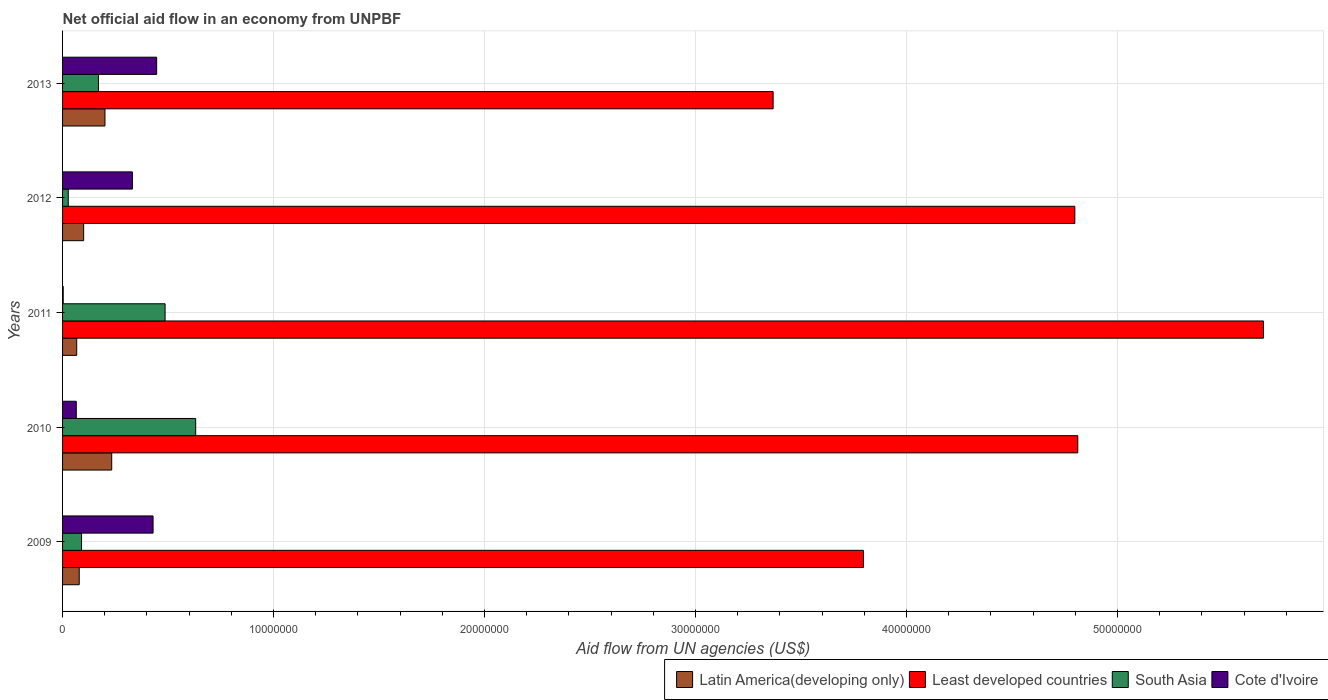How many different coloured bars are there?
Make the answer very short. 4. Are the number of bars on each tick of the Y-axis equal?
Offer a very short reply. Yes. How many bars are there on the 5th tick from the top?
Ensure brevity in your answer.  4. In how many cases, is the number of bars for a given year not equal to the number of legend labels?
Provide a succinct answer. 0. What is the net official aid flow in Least developed countries in 2012?
Make the answer very short. 4.80e+07. Across all years, what is the maximum net official aid flow in South Asia?
Provide a succinct answer. 6.31e+06. Across all years, what is the minimum net official aid flow in South Asia?
Your response must be concise. 2.70e+05. In which year was the net official aid flow in Least developed countries maximum?
Provide a short and direct response. 2011. In which year was the net official aid flow in Cote d'Ivoire minimum?
Provide a succinct answer. 2011. What is the total net official aid flow in Cote d'Ivoire in the graph?
Ensure brevity in your answer.  1.27e+07. What is the difference between the net official aid flow in Latin America(developing only) in 2010 and that in 2011?
Your response must be concise. 1.66e+06. What is the difference between the net official aid flow in Latin America(developing only) in 2010 and the net official aid flow in South Asia in 2013?
Offer a terse response. 6.30e+05. What is the average net official aid flow in Least developed countries per year?
Offer a very short reply. 4.49e+07. In the year 2009, what is the difference between the net official aid flow in Cote d'Ivoire and net official aid flow in Least developed countries?
Provide a succinct answer. -3.37e+07. In how many years, is the net official aid flow in Latin America(developing only) greater than 26000000 US$?
Your response must be concise. 0. What is the ratio of the net official aid flow in Least developed countries in 2010 to that in 2012?
Keep it short and to the point. 1. Is the net official aid flow in Cote d'Ivoire in 2012 less than that in 2013?
Your response must be concise. Yes. What is the difference between the highest and the second highest net official aid flow in Cote d'Ivoire?
Your answer should be very brief. 1.70e+05. What is the difference between the highest and the lowest net official aid flow in Cote d'Ivoire?
Provide a succinct answer. 4.43e+06. In how many years, is the net official aid flow in Cote d'Ivoire greater than the average net official aid flow in Cote d'Ivoire taken over all years?
Ensure brevity in your answer.  3. Is the sum of the net official aid flow in Cote d'Ivoire in 2009 and 2010 greater than the maximum net official aid flow in Least developed countries across all years?
Your answer should be very brief. No. What does the 1st bar from the top in 2009 represents?
Provide a short and direct response. Cote d'Ivoire. What does the 1st bar from the bottom in 2012 represents?
Provide a short and direct response. Latin America(developing only). Is it the case that in every year, the sum of the net official aid flow in South Asia and net official aid flow in Latin America(developing only) is greater than the net official aid flow in Cote d'Ivoire?
Offer a very short reply. No. Are all the bars in the graph horizontal?
Offer a terse response. Yes. How many years are there in the graph?
Your response must be concise. 5. Does the graph contain grids?
Offer a terse response. Yes. How many legend labels are there?
Your answer should be compact. 4. What is the title of the graph?
Give a very brief answer. Net official aid flow in an economy from UNPBF. What is the label or title of the X-axis?
Keep it short and to the point. Aid flow from UN agencies (US$). What is the label or title of the Y-axis?
Your answer should be compact. Years. What is the Aid flow from UN agencies (US$) in Latin America(developing only) in 2009?
Provide a short and direct response. 7.90e+05. What is the Aid flow from UN agencies (US$) in Least developed countries in 2009?
Keep it short and to the point. 3.80e+07. What is the Aid flow from UN agencies (US$) in South Asia in 2009?
Provide a succinct answer. 9.00e+05. What is the Aid flow from UN agencies (US$) of Cote d'Ivoire in 2009?
Your answer should be very brief. 4.29e+06. What is the Aid flow from UN agencies (US$) in Latin America(developing only) in 2010?
Provide a short and direct response. 2.33e+06. What is the Aid flow from UN agencies (US$) of Least developed countries in 2010?
Keep it short and to the point. 4.81e+07. What is the Aid flow from UN agencies (US$) of South Asia in 2010?
Offer a terse response. 6.31e+06. What is the Aid flow from UN agencies (US$) in Cote d'Ivoire in 2010?
Your answer should be compact. 6.50e+05. What is the Aid flow from UN agencies (US$) of Latin America(developing only) in 2011?
Your answer should be very brief. 6.70e+05. What is the Aid flow from UN agencies (US$) in Least developed countries in 2011?
Make the answer very short. 5.69e+07. What is the Aid flow from UN agencies (US$) of South Asia in 2011?
Make the answer very short. 4.86e+06. What is the Aid flow from UN agencies (US$) in Latin America(developing only) in 2012?
Make the answer very short. 1.00e+06. What is the Aid flow from UN agencies (US$) of Least developed countries in 2012?
Your answer should be very brief. 4.80e+07. What is the Aid flow from UN agencies (US$) in South Asia in 2012?
Give a very brief answer. 2.70e+05. What is the Aid flow from UN agencies (US$) in Cote d'Ivoire in 2012?
Provide a short and direct response. 3.31e+06. What is the Aid flow from UN agencies (US$) in Latin America(developing only) in 2013?
Provide a short and direct response. 2.01e+06. What is the Aid flow from UN agencies (US$) in Least developed countries in 2013?
Offer a terse response. 3.37e+07. What is the Aid flow from UN agencies (US$) in South Asia in 2013?
Offer a very short reply. 1.70e+06. What is the Aid flow from UN agencies (US$) of Cote d'Ivoire in 2013?
Offer a very short reply. 4.46e+06. Across all years, what is the maximum Aid flow from UN agencies (US$) of Latin America(developing only)?
Your response must be concise. 2.33e+06. Across all years, what is the maximum Aid flow from UN agencies (US$) in Least developed countries?
Give a very brief answer. 5.69e+07. Across all years, what is the maximum Aid flow from UN agencies (US$) of South Asia?
Ensure brevity in your answer.  6.31e+06. Across all years, what is the maximum Aid flow from UN agencies (US$) of Cote d'Ivoire?
Make the answer very short. 4.46e+06. Across all years, what is the minimum Aid flow from UN agencies (US$) in Latin America(developing only)?
Make the answer very short. 6.70e+05. Across all years, what is the minimum Aid flow from UN agencies (US$) of Least developed countries?
Your response must be concise. 3.37e+07. What is the total Aid flow from UN agencies (US$) in Latin America(developing only) in the graph?
Ensure brevity in your answer.  6.80e+06. What is the total Aid flow from UN agencies (US$) in Least developed countries in the graph?
Your answer should be very brief. 2.25e+08. What is the total Aid flow from UN agencies (US$) in South Asia in the graph?
Give a very brief answer. 1.40e+07. What is the total Aid flow from UN agencies (US$) of Cote d'Ivoire in the graph?
Provide a succinct answer. 1.27e+07. What is the difference between the Aid flow from UN agencies (US$) of Latin America(developing only) in 2009 and that in 2010?
Make the answer very short. -1.54e+06. What is the difference between the Aid flow from UN agencies (US$) in Least developed countries in 2009 and that in 2010?
Ensure brevity in your answer.  -1.02e+07. What is the difference between the Aid flow from UN agencies (US$) in South Asia in 2009 and that in 2010?
Your answer should be compact. -5.41e+06. What is the difference between the Aid flow from UN agencies (US$) in Cote d'Ivoire in 2009 and that in 2010?
Provide a short and direct response. 3.64e+06. What is the difference between the Aid flow from UN agencies (US$) of Latin America(developing only) in 2009 and that in 2011?
Offer a terse response. 1.20e+05. What is the difference between the Aid flow from UN agencies (US$) in Least developed countries in 2009 and that in 2011?
Your answer should be very brief. -1.90e+07. What is the difference between the Aid flow from UN agencies (US$) of South Asia in 2009 and that in 2011?
Ensure brevity in your answer.  -3.96e+06. What is the difference between the Aid flow from UN agencies (US$) of Cote d'Ivoire in 2009 and that in 2011?
Make the answer very short. 4.26e+06. What is the difference between the Aid flow from UN agencies (US$) in Latin America(developing only) in 2009 and that in 2012?
Your answer should be compact. -2.10e+05. What is the difference between the Aid flow from UN agencies (US$) in Least developed countries in 2009 and that in 2012?
Make the answer very short. -1.00e+07. What is the difference between the Aid flow from UN agencies (US$) of South Asia in 2009 and that in 2012?
Provide a succinct answer. 6.30e+05. What is the difference between the Aid flow from UN agencies (US$) in Cote d'Ivoire in 2009 and that in 2012?
Your answer should be compact. 9.80e+05. What is the difference between the Aid flow from UN agencies (US$) in Latin America(developing only) in 2009 and that in 2013?
Your response must be concise. -1.22e+06. What is the difference between the Aid flow from UN agencies (US$) in Least developed countries in 2009 and that in 2013?
Make the answer very short. 4.28e+06. What is the difference between the Aid flow from UN agencies (US$) of South Asia in 2009 and that in 2013?
Offer a terse response. -8.00e+05. What is the difference between the Aid flow from UN agencies (US$) in Cote d'Ivoire in 2009 and that in 2013?
Your response must be concise. -1.70e+05. What is the difference between the Aid flow from UN agencies (US$) of Latin America(developing only) in 2010 and that in 2011?
Give a very brief answer. 1.66e+06. What is the difference between the Aid flow from UN agencies (US$) in Least developed countries in 2010 and that in 2011?
Your answer should be very brief. -8.80e+06. What is the difference between the Aid flow from UN agencies (US$) in South Asia in 2010 and that in 2011?
Provide a short and direct response. 1.45e+06. What is the difference between the Aid flow from UN agencies (US$) of Cote d'Ivoire in 2010 and that in 2011?
Provide a short and direct response. 6.20e+05. What is the difference between the Aid flow from UN agencies (US$) of Latin America(developing only) in 2010 and that in 2012?
Keep it short and to the point. 1.33e+06. What is the difference between the Aid flow from UN agencies (US$) in South Asia in 2010 and that in 2012?
Provide a succinct answer. 6.04e+06. What is the difference between the Aid flow from UN agencies (US$) in Cote d'Ivoire in 2010 and that in 2012?
Offer a terse response. -2.66e+06. What is the difference between the Aid flow from UN agencies (US$) of Least developed countries in 2010 and that in 2013?
Give a very brief answer. 1.44e+07. What is the difference between the Aid flow from UN agencies (US$) in South Asia in 2010 and that in 2013?
Offer a terse response. 4.61e+06. What is the difference between the Aid flow from UN agencies (US$) in Cote d'Ivoire in 2010 and that in 2013?
Offer a terse response. -3.81e+06. What is the difference between the Aid flow from UN agencies (US$) in Latin America(developing only) in 2011 and that in 2012?
Your answer should be very brief. -3.30e+05. What is the difference between the Aid flow from UN agencies (US$) of Least developed countries in 2011 and that in 2012?
Make the answer very short. 8.94e+06. What is the difference between the Aid flow from UN agencies (US$) of South Asia in 2011 and that in 2012?
Ensure brevity in your answer.  4.59e+06. What is the difference between the Aid flow from UN agencies (US$) in Cote d'Ivoire in 2011 and that in 2012?
Provide a short and direct response. -3.28e+06. What is the difference between the Aid flow from UN agencies (US$) in Latin America(developing only) in 2011 and that in 2013?
Keep it short and to the point. -1.34e+06. What is the difference between the Aid flow from UN agencies (US$) of Least developed countries in 2011 and that in 2013?
Ensure brevity in your answer.  2.32e+07. What is the difference between the Aid flow from UN agencies (US$) of South Asia in 2011 and that in 2013?
Offer a very short reply. 3.16e+06. What is the difference between the Aid flow from UN agencies (US$) of Cote d'Ivoire in 2011 and that in 2013?
Provide a succinct answer. -4.43e+06. What is the difference between the Aid flow from UN agencies (US$) in Latin America(developing only) in 2012 and that in 2013?
Offer a very short reply. -1.01e+06. What is the difference between the Aid flow from UN agencies (US$) in Least developed countries in 2012 and that in 2013?
Offer a very short reply. 1.43e+07. What is the difference between the Aid flow from UN agencies (US$) of South Asia in 2012 and that in 2013?
Offer a terse response. -1.43e+06. What is the difference between the Aid flow from UN agencies (US$) of Cote d'Ivoire in 2012 and that in 2013?
Keep it short and to the point. -1.15e+06. What is the difference between the Aid flow from UN agencies (US$) in Latin America(developing only) in 2009 and the Aid flow from UN agencies (US$) in Least developed countries in 2010?
Provide a short and direct response. -4.73e+07. What is the difference between the Aid flow from UN agencies (US$) of Latin America(developing only) in 2009 and the Aid flow from UN agencies (US$) of South Asia in 2010?
Offer a terse response. -5.52e+06. What is the difference between the Aid flow from UN agencies (US$) of Latin America(developing only) in 2009 and the Aid flow from UN agencies (US$) of Cote d'Ivoire in 2010?
Give a very brief answer. 1.40e+05. What is the difference between the Aid flow from UN agencies (US$) in Least developed countries in 2009 and the Aid flow from UN agencies (US$) in South Asia in 2010?
Your answer should be compact. 3.16e+07. What is the difference between the Aid flow from UN agencies (US$) in Least developed countries in 2009 and the Aid flow from UN agencies (US$) in Cote d'Ivoire in 2010?
Ensure brevity in your answer.  3.73e+07. What is the difference between the Aid flow from UN agencies (US$) of South Asia in 2009 and the Aid flow from UN agencies (US$) of Cote d'Ivoire in 2010?
Your answer should be very brief. 2.50e+05. What is the difference between the Aid flow from UN agencies (US$) in Latin America(developing only) in 2009 and the Aid flow from UN agencies (US$) in Least developed countries in 2011?
Provide a short and direct response. -5.61e+07. What is the difference between the Aid flow from UN agencies (US$) of Latin America(developing only) in 2009 and the Aid flow from UN agencies (US$) of South Asia in 2011?
Make the answer very short. -4.07e+06. What is the difference between the Aid flow from UN agencies (US$) in Latin America(developing only) in 2009 and the Aid flow from UN agencies (US$) in Cote d'Ivoire in 2011?
Your answer should be very brief. 7.60e+05. What is the difference between the Aid flow from UN agencies (US$) in Least developed countries in 2009 and the Aid flow from UN agencies (US$) in South Asia in 2011?
Keep it short and to the point. 3.31e+07. What is the difference between the Aid flow from UN agencies (US$) in Least developed countries in 2009 and the Aid flow from UN agencies (US$) in Cote d'Ivoire in 2011?
Keep it short and to the point. 3.79e+07. What is the difference between the Aid flow from UN agencies (US$) in South Asia in 2009 and the Aid flow from UN agencies (US$) in Cote d'Ivoire in 2011?
Provide a short and direct response. 8.70e+05. What is the difference between the Aid flow from UN agencies (US$) of Latin America(developing only) in 2009 and the Aid flow from UN agencies (US$) of Least developed countries in 2012?
Ensure brevity in your answer.  -4.72e+07. What is the difference between the Aid flow from UN agencies (US$) in Latin America(developing only) in 2009 and the Aid flow from UN agencies (US$) in South Asia in 2012?
Your response must be concise. 5.20e+05. What is the difference between the Aid flow from UN agencies (US$) in Latin America(developing only) in 2009 and the Aid flow from UN agencies (US$) in Cote d'Ivoire in 2012?
Your response must be concise. -2.52e+06. What is the difference between the Aid flow from UN agencies (US$) in Least developed countries in 2009 and the Aid flow from UN agencies (US$) in South Asia in 2012?
Make the answer very short. 3.77e+07. What is the difference between the Aid flow from UN agencies (US$) in Least developed countries in 2009 and the Aid flow from UN agencies (US$) in Cote d'Ivoire in 2012?
Provide a short and direct response. 3.46e+07. What is the difference between the Aid flow from UN agencies (US$) in South Asia in 2009 and the Aid flow from UN agencies (US$) in Cote d'Ivoire in 2012?
Your answer should be compact. -2.41e+06. What is the difference between the Aid flow from UN agencies (US$) of Latin America(developing only) in 2009 and the Aid flow from UN agencies (US$) of Least developed countries in 2013?
Provide a succinct answer. -3.29e+07. What is the difference between the Aid flow from UN agencies (US$) in Latin America(developing only) in 2009 and the Aid flow from UN agencies (US$) in South Asia in 2013?
Ensure brevity in your answer.  -9.10e+05. What is the difference between the Aid flow from UN agencies (US$) in Latin America(developing only) in 2009 and the Aid flow from UN agencies (US$) in Cote d'Ivoire in 2013?
Offer a very short reply. -3.67e+06. What is the difference between the Aid flow from UN agencies (US$) in Least developed countries in 2009 and the Aid flow from UN agencies (US$) in South Asia in 2013?
Offer a very short reply. 3.63e+07. What is the difference between the Aid flow from UN agencies (US$) in Least developed countries in 2009 and the Aid flow from UN agencies (US$) in Cote d'Ivoire in 2013?
Your answer should be very brief. 3.35e+07. What is the difference between the Aid flow from UN agencies (US$) in South Asia in 2009 and the Aid flow from UN agencies (US$) in Cote d'Ivoire in 2013?
Provide a succinct answer. -3.56e+06. What is the difference between the Aid flow from UN agencies (US$) in Latin America(developing only) in 2010 and the Aid flow from UN agencies (US$) in Least developed countries in 2011?
Provide a short and direct response. -5.46e+07. What is the difference between the Aid flow from UN agencies (US$) of Latin America(developing only) in 2010 and the Aid flow from UN agencies (US$) of South Asia in 2011?
Your response must be concise. -2.53e+06. What is the difference between the Aid flow from UN agencies (US$) of Latin America(developing only) in 2010 and the Aid flow from UN agencies (US$) of Cote d'Ivoire in 2011?
Give a very brief answer. 2.30e+06. What is the difference between the Aid flow from UN agencies (US$) of Least developed countries in 2010 and the Aid flow from UN agencies (US$) of South Asia in 2011?
Provide a short and direct response. 4.33e+07. What is the difference between the Aid flow from UN agencies (US$) in Least developed countries in 2010 and the Aid flow from UN agencies (US$) in Cote d'Ivoire in 2011?
Offer a very short reply. 4.81e+07. What is the difference between the Aid flow from UN agencies (US$) of South Asia in 2010 and the Aid flow from UN agencies (US$) of Cote d'Ivoire in 2011?
Provide a succinct answer. 6.28e+06. What is the difference between the Aid flow from UN agencies (US$) of Latin America(developing only) in 2010 and the Aid flow from UN agencies (US$) of Least developed countries in 2012?
Offer a terse response. -4.56e+07. What is the difference between the Aid flow from UN agencies (US$) of Latin America(developing only) in 2010 and the Aid flow from UN agencies (US$) of South Asia in 2012?
Provide a short and direct response. 2.06e+06. What is the difference between the Aid flow from UN agencies (US$) in Latin America(developing only) in 2010 and the Aid flow from UN agencies (US$) in Cote d'Ivoire in 2012?
Your answer should be compact. -9.80e+05. What is the difference between the Aid flow from UN agencies (US$) in Least developed countries in 2010 and the Aid flow from UN agencies (US$) in South Asia in 2012?
Offer a terse response. 4.78e+07. What is the difference between the Aid flow from UN agencies (US$) of Least developed countries in 2010 and the Aid flow from UN agencies (US$) of Cote d'Ivoire in 2012?
Keep it short and to the point. 4.48e+07. What is the difference between the Aid flow from UN agencies (US$) in South Asia in 2010 and the Aid flow from UN agencies (US$) in Cote d'Ivoire in 2012?
Ensure brevity in your answer.  3.00e+06. What is the difference between the Aid flow from UN agencies (US$) of Latin America(developing only) in 2010 and the Aid flow from UN agencies (US$) of Least developed countries in 2013?
Keep it short and to the point. -3.14e+07. What is the difference between the Aid flow from UN agencies (US$) of Latin America(developing only) in 2010 and the Aid flow from UN agencies (US$) of South Asia in 2013?
Offer a terse response. 6.30e+05. What is the difference between the Aid flow from UN agencies (US$) in Latin America(developing only) in 2010 and the Aid flow from UN agencies (US$) in Cote d'Ivoire in 2013?
Your answer should be very brief. -2.13e+06. What is the difference between the Aid flow from UN agencies (US$) of Least developed countries in 2010 and the Aid flow from UN agencies (US$) of South Asia in 2013?
Keep it short and to the point. 4.64e+07. What is the difference between the Aid flow from UN agencies (US$) in Least developed countries in 2010 and the Aid flow from UN agencies (US$) in Cote d'Ivoire in 2013?
Give a very brief answer. 4.37e+07. What is the difference between the Aid flow from UN agencies (US$) of South Asia in 2010 and the Aid flow from UN agencies (US$) of Cote d'Ivoire in 2013?
Keep it short and to the point. 1.85e+06. What is the difference between the Aid flow from UN agencies (US$) in Latin America(developing only) in 2011 and the Aid flow from UN agencies (US$) in Least developed countries in 2012?
Your answer should be compact. -4.73e+07. What is the difference between the Aid flow from UN agencies (US$) in Latin America(developing only) in 2011 and the Aid flow from UN agencies (US$) in Cote d'Ivoire in 2012?
Ensure brevity in your answer.  -2.64e+06. What is the difference between the Aid flow from UN agencies (US$) in Least developed countries in 2011 and the Aid flow from UN agencies (US$) in South Asia in 2012?
Keep it short and to the point. 5.66e+07. What is the difference between the Aid flow from UN agencies (US$) in Least developed countries in 2011 and the Aid flow from UN agencies (US$) in Cote d'Ivoire in 2012?
Your answer should be compact. 5.36e+07. What is the difference between the Aid flow from UN agencies (US$) of South Asia in 2011 and the Aid flow from UN agencies (US$) of Cote d'Ivoire in 2012?
Ensure brevity in your answer.  1.55e+06. What is the difference between the Aid flow from UN agencies (US$) of Latin America(developing only) in 2011 and the Aid flow from UN agencies (US$) of Least developed countries in 2013?
Keep it short and to the point. -3.30e+07. What is the difference between the Aid flow from UN agencies (US$) in Latin America(developing only) in 2011 and the Aid flow from UN agencies (US$) in South Asia in 2013?
Your response must be concise. -1.03e+06. What is the difference between the Aid flow from UN agencies (US$) of Latin America(developing only) in 2011 and the Aid flow from UN agencies (US$) of Cote d'Ivoire in 2013?
Provide a short and direct response. -3.79e+06. What is the difference between the Aid flow from UN agencies (US$) of Least developed countries in 2011 and the Aid flow from UN agencies (US$) of South Asia in 2013?
Your response must be concise. 5.52e+07. What is the difference between the Aid flow from UN agencies (US$) of Least developed countries in 2011 and the Aid flow from UN agencies (US$) of Cote d'Ivoire in 2013?
Keep it short and to the point. 5.25e+07. What is the difference between the Aid flow from UN agencies (US$) in Latin America(developing only) in 2012 and the Aid flow from UN agencies (US$) in Least developed countries in 2013?
Your answer should be very brief. -3.27e+07. What is the difference between the Aid flow from UN agencies (US$) of Latin America(developing only) in 2012 and the Aid flow from UN agencies (US$) of South Asia in 2013?
Provide a succinct answer. -7.00e+05. What is the difference between the Aid flow from UN agencies (US$) of Latin America(developing only) in 2012 and the Aid flow from UN agencies (US$) of Cote d'Ivoire in 2013?
Ensure brevity in your answer.  -3.46e+06. What is the difference between the Aid flow from UN agencies (US$) in Least developed countries in 2012 and the Aid flow from UN agencies (US$) in South Asia in 2013?
Provide a succinct answer. 4.63e+07. What is the difference between the Aid flow from UN agencies (US$) in Least developed countries in 2012 and the Aid flow from UN agencies (US$) in Cote d'Ivoire in 2013?
Offer a very short reply. 4.35e+07. What is the difference between the Aid flow from UN agencies (US$) of South Asia in 2012 and the Aid flow from UN agencies (US$) of Cote d'Ivoire in 2013?
Make the answer very short. -4.19e+06. What is the average Aid flow from UN agencies (US$) in Latin America(developing only) per year?
Your answer should be very brief. 1.36e+06. What is the average Aid flow from UN agencies (US$) of Least developed countries per year?
Ensure brevity in your answer.  4.49e+07. What is the average Aid flow from UN agencies (US$) of South Asia per year?
Your answer should be compact. 2.81e+06. What is the average Aid flow from UN agencies (US$) in Cote d'Ivoire per year?
Make the answer very short. 2.55e+06. In the year 2009, what is the difference between the Aid flow from UN agencies (US$) of Latin America(developing only) and Aid flow from UN agencies (US$) of Least developed countries?
Provide a succinct answer. -3.72e+07. In the year 2009, what is the difference between the Aid flow from UN agencies (US$) of Latin America(developing only) and Aid flow from UN agencies (US$) of South Asia?
Provide a short and direct response. -1.10e+05. In the year 2009, what is the difference between the Aid flow from UN agencies (US$) of Latin America(developing only) and Aid flow from UN agencies (US$) of Cote d'Ivoire?
Offer a terse response. -3.50e+06. In the year 2009, what is the difference between the Aid flow from UN agencies (US$) of Least developed countries and Aid flow from UN agencies (US$) of South Asia?
Your answer should be very brief. 3.71e+07. In the year 2009, what is the difference between the Aid flow from UN agencies (US$) of Least developed countries and Aid flow from UN agencies (US$) of Cote d'Ivoire?
Your answer should be very brief. 3.37e+07. In the year 2009, what is the difference between the Aid flow from UN agencies (US$) in South Asia and Aid flow from UN agencies (US$) in Cote d'Ivoire?
Offer a very short reply. -3.39e+06. In the year 2010, what is the difference between the Aid flow from UN agencies (US$) in Latin America(developing only) and Aid flow from UN agencies (US$) in Least developed countries?
Offer a terse response. -4.58e+07. In the year 2010, what is the difference between the Aid flow from UN agencies (US$) in Latin America(developing only) and Aid flow from UN agencies (US$) in South Asia?
Your answer should be compact. -3.98e+06. In the year 2010, what is the difference between the Aid flow from UN agencies (US$) of Latin America(developing only) and Aid flow from UN agencies (US$) of Cote d'Ivoire?
Your answer should be very brief. 1.68e+06. In the year 2010, what is the difference between the Aid flow from UN agencies (US$) in Least developed countries and Aid flow from UN agencies (US$) in South Asia?
Give a very brief answer. 4.18e+07. In the year 2010, what is the difference between the Aid flow from UN agencies (US$) in Least developed countries and Aid flow from UN agencies (US$) in Cote d'Ivoire?
Give a very brief answer. 4.75e+07. In the year 2010, what is the difference between the Aid flow from UN agencies (US$) of South Asia and Aid flow from UN agencies (US$) of Cote d'Ivoire?
Provide a succinct answer. 5.66e+06. In the year 2011, what is the difference between the Aid flow from UN agencies (US$) of Latin America(developing only) and Aid flow from UN agencies (US$) of Least developed countries?
Make the answer very short. -5.62e+07. In the year 2011, what is the difference between the Aid flow from UN agencies (US$) of Latin America(developing only) and Aid flow from UN agencies (US$) of South Asia?
Give a very brief answer. -4.19e+06. In the year 2011, what is the difference between the Aid flow from UN agencies (US$) in Latin America(developing only) and Aid flow from UN agencies (US$) in Cote d'Ivoire?
Keep it short and to the point. 6.40e+05. In the year 2011, what is the difference between the Aid flow from UN agencies (US$) in Least developed countries and Aid flow from UN agencies (US$) in South Asia?
Your answer should be compact. 5.21e+07. In the year 2011, what is the difference between the Aid flow from UN agencies (US$) of Least developed countries and Aid flow from UN agencies (US$) of Cote d'Ivoire?
Your answer should be very brief. 5.69e+07. In the year 2011, what is the difference between the Aid flow from UN agencies (US$) in South Asia and Aid flow from UN agencies (US$) in Cote d'Ivoire?
Your answer should be compact. 4.83e+06. In the year 2012, what is the difference between the Aid flow from UN agencies (US$) of Latin America(developing only) and Aid flow from UN agencies (US$) of Least developed countries?
Provide a succinct answer. -4.70e+07. In the year 2012, what is the difference between the Aid flow from UN agencies (US$) in Latin America(developing only) and Aid flow from UN agencies (US$) in South Asia?
Your response must be concise. 7.30e+05. In the year 2012, what is the difference between the Aid flow from UN agencies (US$) of Latin America(developing only) and Aid flow from UN agencies (US$) of Cote d'Ivoire?
Give a very brief answer. -2.31e+06. In the year 2012, what is the difference between the Aid flow from UN agencies (US$) of Least developed countries and Aid flow from UN agencies (US$) of South Asia?
Your answer should be compact. 4.77e+07. In the year 2012, what is the difference between the Aid flow from UN agencies (US$) in Least developed countries and Aid flow from UN agencies (US$) in Cote d'Ivoire?
Your answer should be very brief. 4.47e+07. In the year 2012, what is the difference between the Aid flow from UN agencies (US$) in South Asia and Aid flow from UN agencies (US$) in Cote d'Ivoire?
Offer a terse response. -3.04e+06. In the year 2013, what is the difference between the Aid flow from UN agencies (US$) of Latin America(developing only) and Aid flow from UN agencies (US$) of Least developed countries?
Make the answer very short. -3.17e+07. In the year 2013, what is the difference between the Aid flow from UN agencies (US$) in Latin America(developing only) and Aid flow from UN agencies (US$) in South Asia?
Provide a short and direct response. 3.10e+05. In the year 2013, what is the difference between the Aid flow from UN agencies (US$) in Latin America(developing only) and Aid flow from UN agencies (US$) in Cote d'Ivoire?
Give a very brief answer. -2.45e+06. In the year 2013, what is the difference between the Aid flow from UN agencies (US$) of Least developed countries and Aid flow from UN agencies (US$) of South Asia?
Offer a very short reply. 3.20e+07. In the year 2013, what is the difference between the Aid flow from UN agencies (US$) in Least developed countries and Aid flow from UN agencies (US$) in Cote d'Ivoire?
Make the answer very short. 2.92e+07. In the year 2013, what is the difference between the Aid flow from UN agencies (US$) of South Asia and Aid flow from UN agencies (US$) of Cote d'Ivoire?
Offer a very short reply. -2.76e+06. What is the ratio of the Aid flow from UN agencies (US$) in Latin America(developing only) in 2009 to that in 2010?
Provide a succinct answer. 0.34. What is the ratio of the Aid flow from UN agencies (US$) in Least developed countries in 2009 to that in 2010?
Keep it short and to the point. 0.79. What is the ratio of the Aid flow from UN agencies (US$) of South Asia in 2009 to that in 2010?
Your response must be concise. 0.14. What is the ratio of the Aid flow from UN agencies (US$) of Latin America(developing only) in 2009 to that in 2011?
Your response must be concise. 1.18. What is the ratio of the Aid flow from UN agencies (US$) of Least developed countries in 2009 to that in 2011?
Offer a very short reply. 0.67. What is the ratio of the Aid flow from UN agencies (US$) of South Asia in 2009 to that in 2011?
Provide a succinct answer. 0.19. What is the ratio of the Aid flow from UN agencies (US$) in Cote d'Ivoire in 2009 to that in 2011?
Provide a short and direct response. 143. What is the ratio of the Aid flow from UN agencies (US$) in Latin America(developing only) in 2009 to that in 2012?
Offer a very short reply. 0.79. What is the ratio of the Aid flow from UN agencies (US$) of Least developed countries in 2009 to that in 2012?
Make the answer very short. 0.79. What is the ratio of the Aid flow from UN agencies (US$) in Cote d'Ivoire in 2009 to that in 2012?
Your answer should be compact. 1.3. What is the ratio of the Aid flow from UN agencies (US$) of Latin America(developing only) in 2009 to that in 2013?
Make the answer very short. 0.39. What is the ratio of the Aid flow from UN agencies (US$) in Least developed countries in 2009 to that in 2013?
Your answer should be very brief. 1.13. What is the ratio of the Aid flow from UN agencies (US$) of South Asia in 2009 to that in 2013?
Your answer should be compact. 0.53. What is the ratio of the Aid flow from UN agencies (US$) in Cote d'Ivoire in 2009 to that in 2013?
Offer a terse response. 0.96. What is the ratio of the Aid flow from UN agencies (US$) in Latin America(developing only) in 2010 to that in 2011?
Your response must be concise. 3.48. What is the ratio of the Aid flow from UN agencies (US$) in Least developed countries in 2010 to that in 2011?
Ensure brevity in your answer.  0.85. What is the ratio of the Aid flow from UN agencies (US$) in South Asia in 2010 to that in 2011?
Offer a very short reply. 1.3. What is the ratio of the Aid flow from UN agencies (US$) in Cote d'Ivoire in 2010 to that in 2011?
Offer a very short reply. 21.67. What is the ratio of the Aid flow from UN agencies (US$) of Latin America(developing only) in 2010 to that in 2012?
Your response must be concise. 2.33. What is the ratio of the Aid flow from UN agencies (US$) in Least developed countries in 2010 to that in 2012?
Give a very brief answer. 1. What is the ratio of the Aid flow from UN agencies (US$) of South Asia in 2010 to that in 2012?
Make the answer very short. 23.37. What is the ratio of the Aid flow from UN agencies (US$) in Cote d'Ivoire in 2010 to that in 2012?
Ensure brevity in your answer.  0.2. What is the ratio of the Aid flow from UN agencies (US$) of Latin America(developing only) in 2010 to that in 2013?
Your answer should be very brief. 1.16. What is the ratio of the Aid flow from UN agencies (US$) of Least developed countries in 2010 to that in 2013?
Your answer should be very brief. 1.43. What is the ratio of the Aid flow from UN agencies (US$) in South Asia in 2010 to that in 2013?
Give a very brief answer. 3.71. What is the ratio of the Aid flow from UN agencies (US$) in Cote d'Ivoire in 2010 to that in 2013?
Give a very brief answer. 0.15. What is the ratio of the Aid flow from UN agencies (US$) in Latin America(developing only) in 2011 to that in 2012?
Make the answer very short. 0.67. What is the ratio of the Aid flow from UN agencies (US$) of Least developed countries in 2011 to that in 2012?
Your answer should be very brief. 1.19. What is the ratio of the Aid flow from UN agencies (US$) in Cote d'Ivoire in 2011 to that in 2012?
Provide a succinct answer. 0.01. What is the ratio of the Aid flow from UN agencies (US$) in Latin America(developing only) in 2011 to that in 2013?
Give a very brief answer. 0.33. What is the ratio of the Aid flow from UN agencies (US$) in Least developed countries in 2011 to that in 2013?
Offer a terse response. 1.69. What is the ratio of the Aid flow from UN agencies (US$) in South Asia in 2011 to that in 2013?
Keep it short and to the point. 2.86. What is the ratio of the Aid flow from UN agencies (US$) of Cote d'Ivoire in 2011 to that in 2013?
Your response must be concise. 0.01. What is the ratio of the Aid flow from UN agencies (US$) of Latin America(developing only) in 2012 to that in 2013?
Make the answer very short. 0.5. What is the ratio of the Aid flow from UN agencies (US$) in Least developed countries in 2012 to that in 2013?
Offer a very short reply. 1.42. What is the ratio of the Aid flow from UN agencies (US$) in South Asia in 2012 to that in 2013?
Keep it short and to the point. 0.16. What is the ratio of the Aid flow from UN agencies (US$) in Cote d'Ivoire in 2012 to that in 2013?
Your response must be concise. 0.74. What is the difference between the highest and the second highest Aid flow from UN agencies (US$) in Latin America(developing only)?
Keep it short and to the point. 3.20e+05. What is the difference between the highest and the second highest Aid flow from UN agencies (US$) of Least developed countries?
Give a very brief answer. 8.80e+06. What is the difference between the highest and the second highest Aid flow from UN agencies (US$) in South Asia?
Your response must be concise. 1.45e+06. What is the difference between the highest and the second highest Aid flow from UN agencies (US$) in Cote d'Ivoire?
Your response must be concise. 1.70e+05. What is the difference between the highest and the lowest Aid flow from UN agencies (US$) in Latin America(developing only)?
Offer a very short reply. 1.66e+06. What is the difference between the highest and the lowest Aid flow from UN agencies (US$) of Least developed countries?
Your response must be concise. 2.32e+07. What is the difference between the highest and the lowest Aid flow from UN agencies (US$) in South Asia?
Make the answer very short. 6.04e+06. What is the difference between the highest and the lowest Aid flow from UN agencies (US$) of Cote d'Ivoire?
Offer a very short reply. 4.43e+06. 